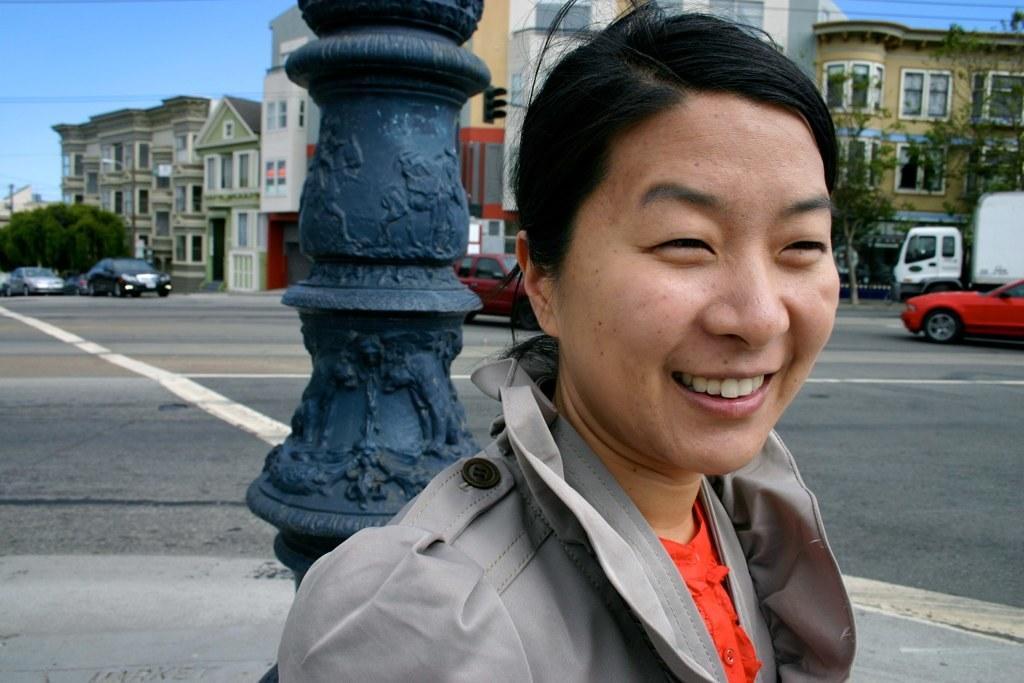In one or two sentences, can you explain what this image depicts? In this picture we can see a woman smiling. There is a pole on the path. Few vehicles are visible on the road. There are some trees and buildings visible in the background. We can see a few wires on top. 